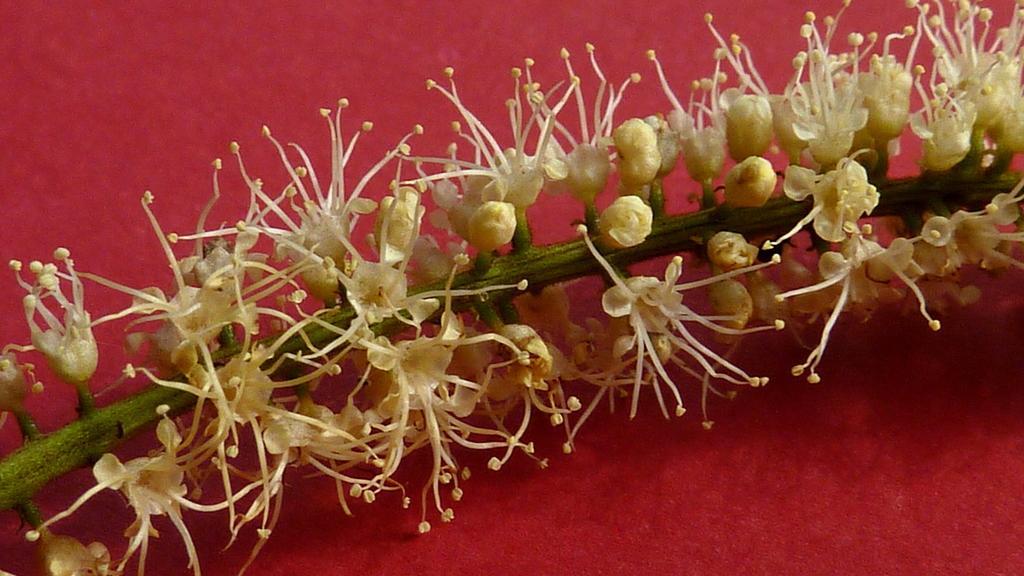Could you give a brief overview of what you see in this image? In the image we can see there are flowers on the plant and it is kept on the table. 